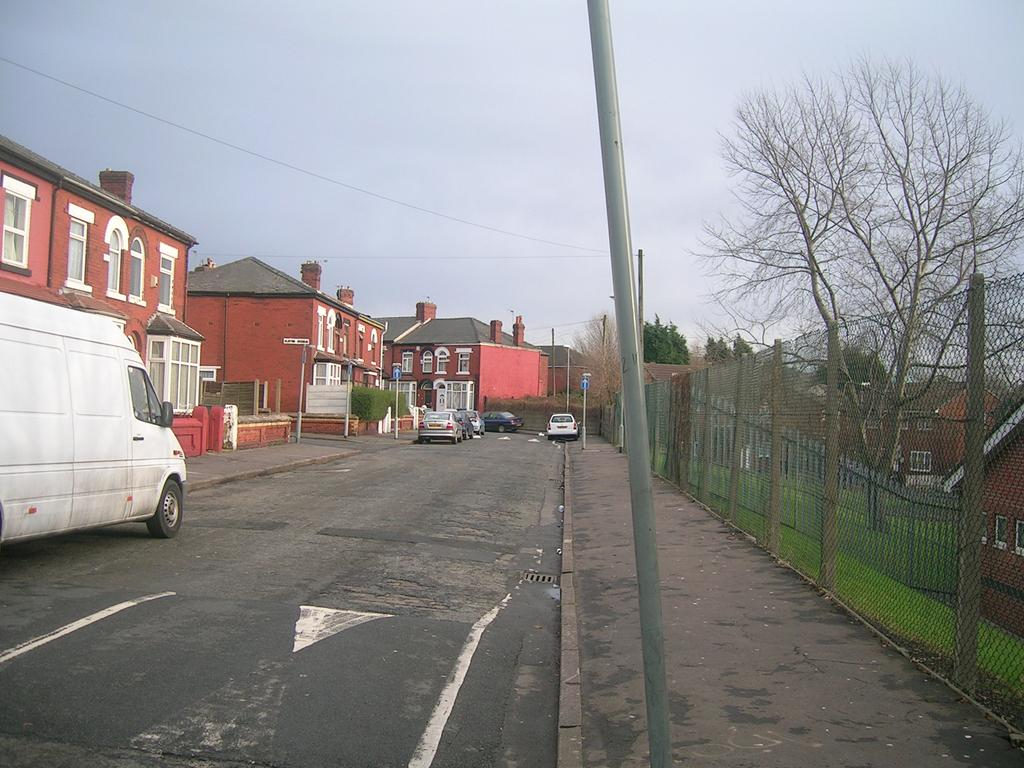What can be seen on the road in the image? There are vehicles on the road in the image. What structures are visible in the image? There are buildings visible in the image. What type of vegetation is present in the image? Trees are present in the image. What type of barrier can be seen in the image? There is a fence in the image. What are the tall, thin objects in the image? There are poles in the image. What other objects can be seen in the image? There are other objects in the image, but their specific details are not mentioned in the provided facts. What is visible in the background of the image? The sky is visible in the background of the image. Can you see any fairies flying around the trees in the image? There is no mention of fairies in the provided facts, and therefore we cannot determine their presence in the image. What type of rat is sitting on the fence in the image? There is no mention of a rat in the provided facts, and therefore we cannot determine its presence in the image. 